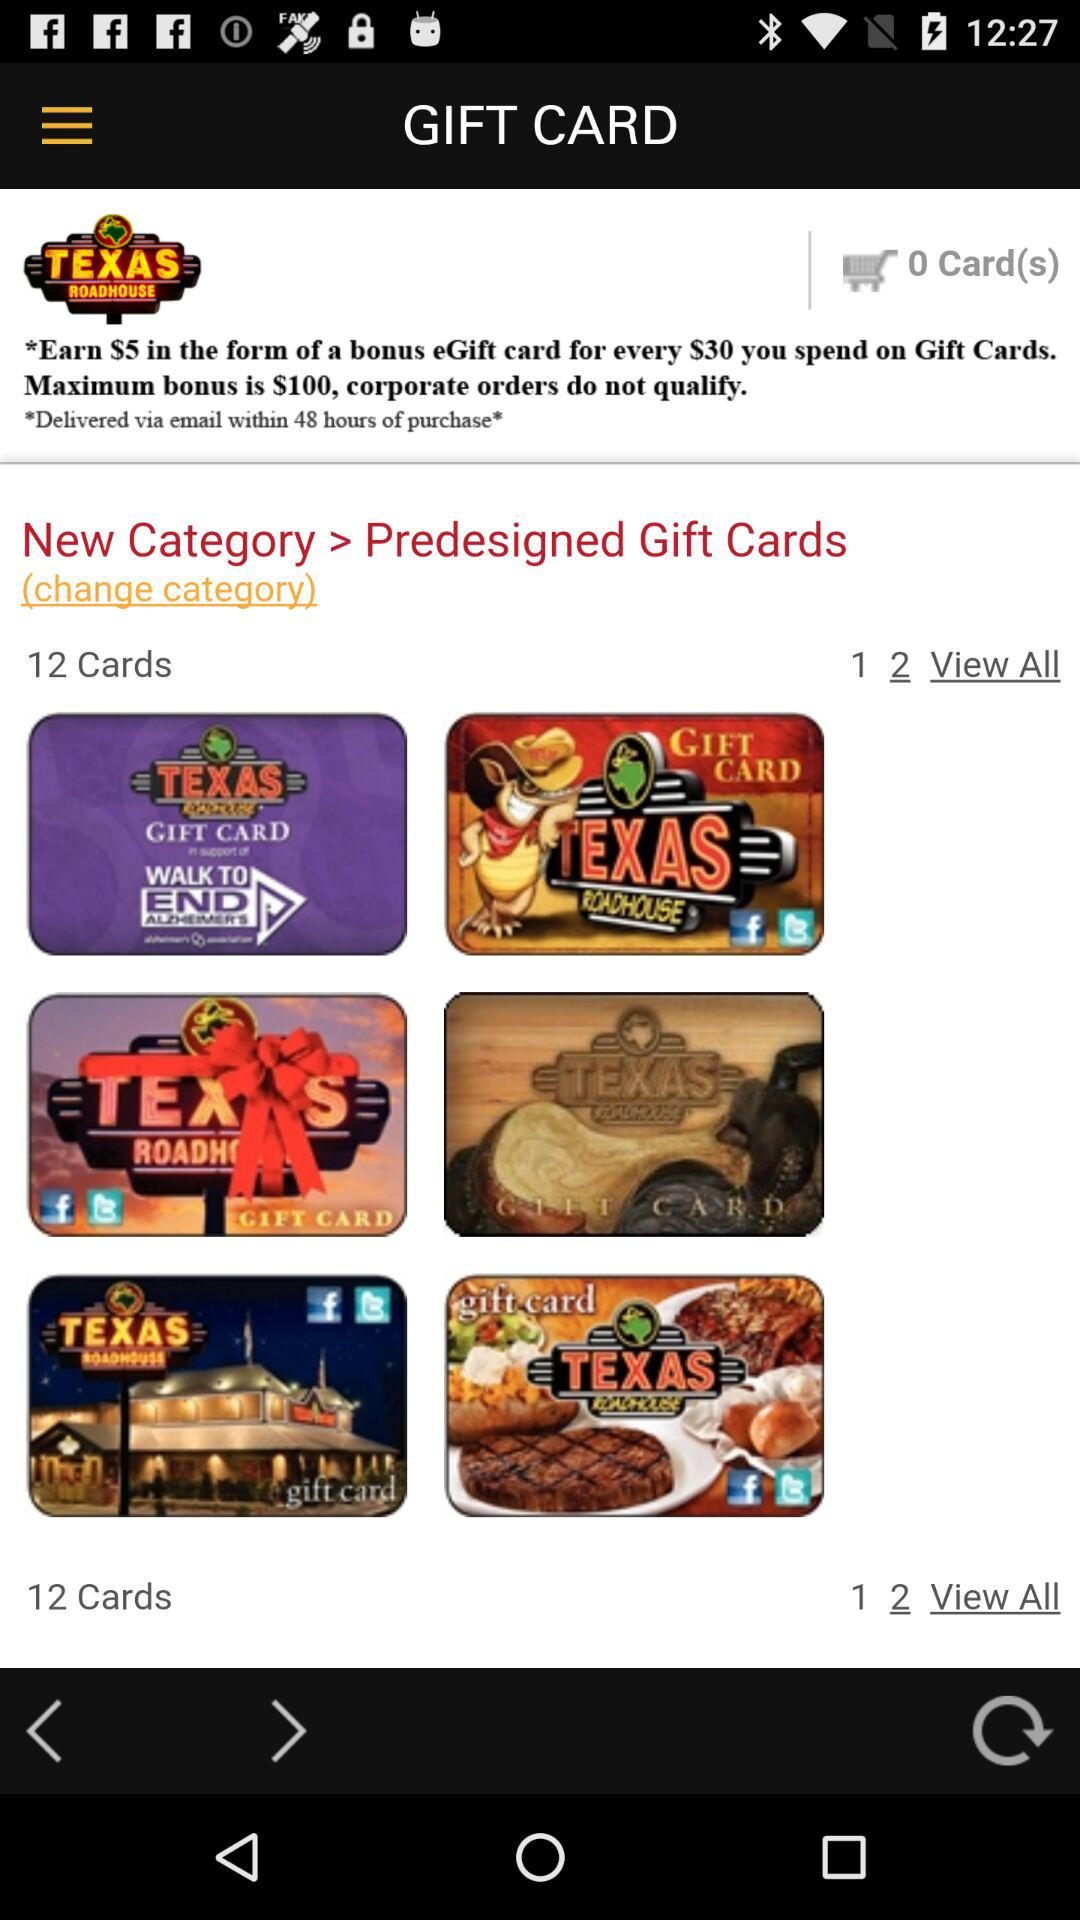How much can we earn for spending $30 on Gift Cards? You can earn $5 in the form of a bonus eGift card for spending $30 on Gift Cards. 